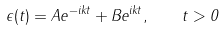Convert formula to latex. <formula><loc_0><loc_0><loc_500><loc_500>\epsilon ( t ) = A e ^ { - i k t } + B e ^ { i k t } , \quad t > 0</formula> 